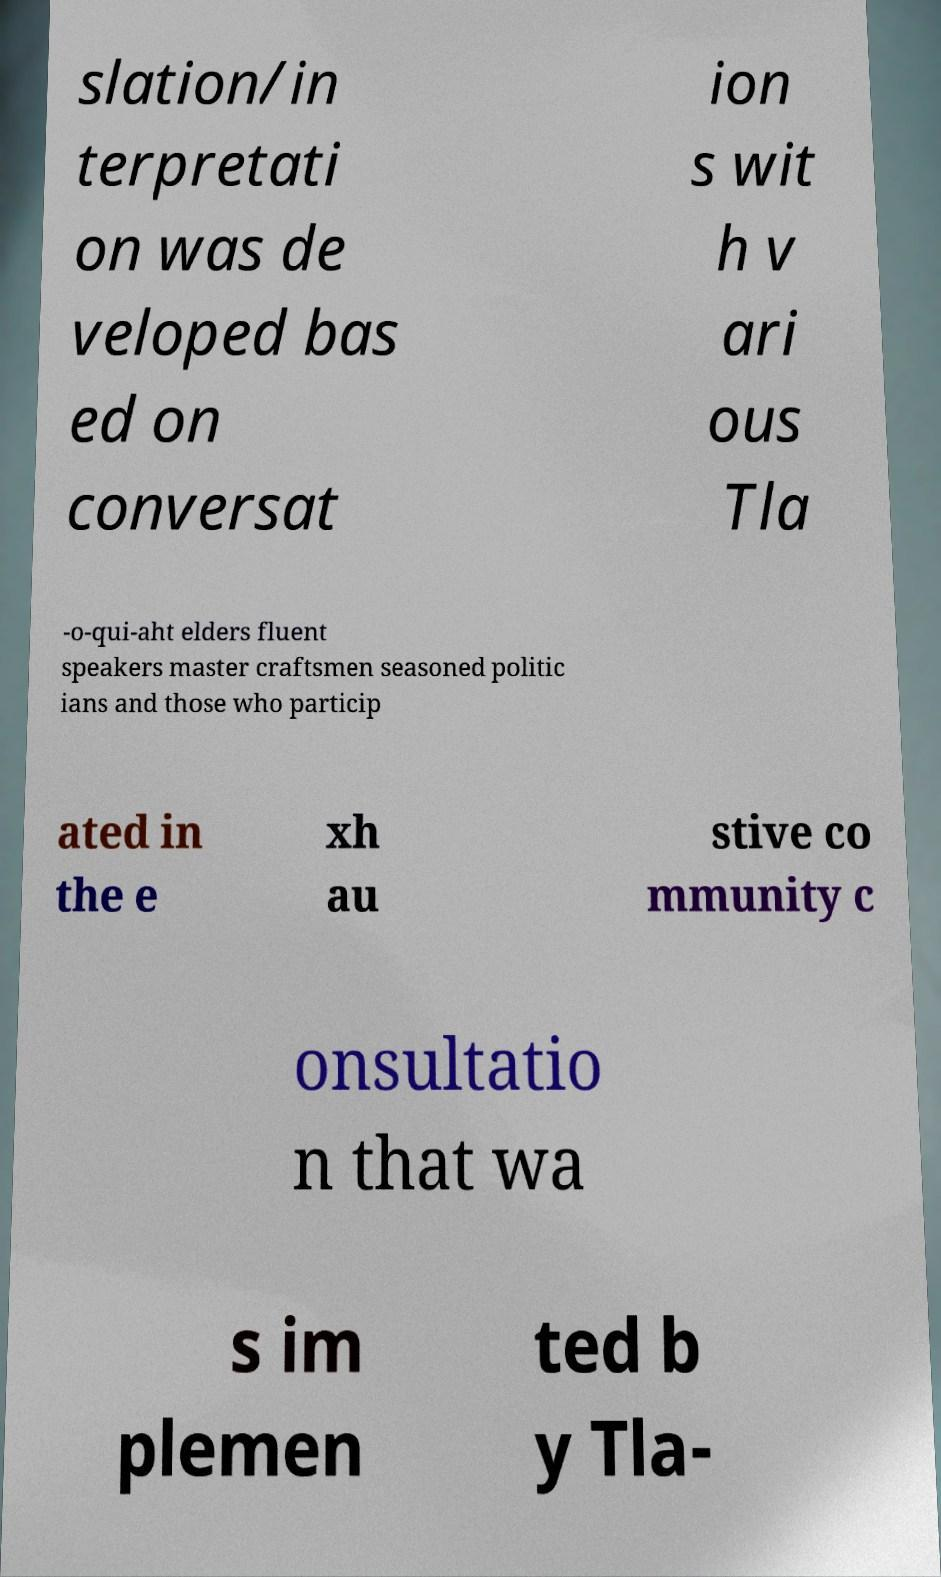Can you read and provide the text displayed in the image?This photo seems to have some interesting text. Can you extract and type it out for me? slation/in terpretati on was de veloped bas ed on conversat ion s wit h v ari ous Tla -o-qui-aht elders fluent speakers master craftsmen seasoned politic ians and those who particip ated in the e xh au stive co mmunity c onsultatio n that wa s im plemen ted b y Tla- 